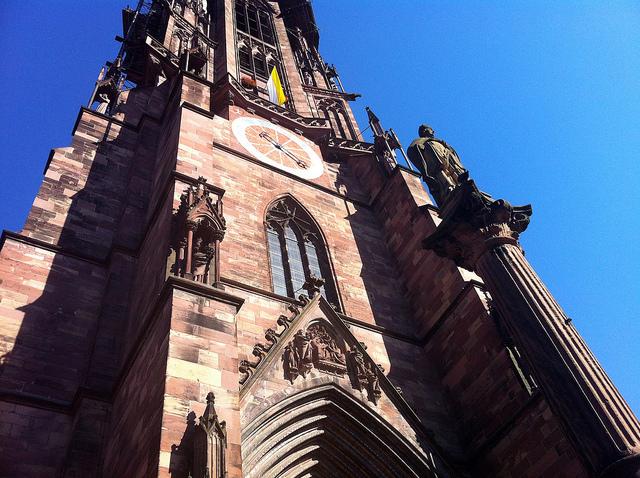Is the sky sunny or overcast?
Give a very brief answer. Sunny. Is there a clock on the building?
Answer briefly. Yes. Is this an old hotel?
Quick response, please. No. Is the sky blue?
Give a very brief answer. Yes. 